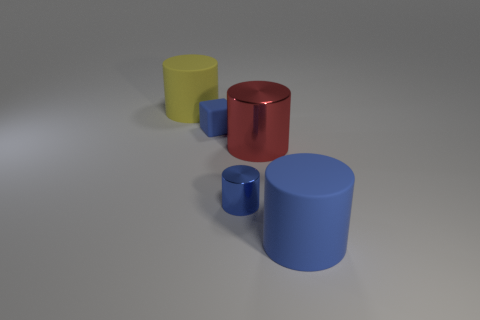There is a large object that is the same color as the matte block; what material is it?
Offer a terse response. Rubber. There is a metal cylinder to the left of the red cylinder; what color is it?
Provide a succinct answer. Blue. What number of cylinders are small things or large blue matte things?
Your response must be concise. 2. There is a matte cylinder that is on the right side of the big thing that is behind the red cylinder; what size is it?
Your answer should be very brief. Large. Is the color of the large metallic cylinder the same as the big rubber cylinder behind the large blue rubber object?
Your answer should be compact. No. There is a rubber block; how many red metal objects are to the left of it?
Your answer should be very brief. 0. Are there fewer big red shiny balls than blue rubber blocks?
Give a very brief answer. Yes. How big is the thing that is in front of the large yellow object and on the left side of the tiny cylinder?
Make the answer very short. Small. Is the color of the large matte cylinder that is left of the large blue cylinder the same as the tiny shiny cylinder?
Provide a short and direct response. No. Is the number of things to the right of the blue rubber cylinder less than the number of large red metal spheres?
Your response must be concise. No. 